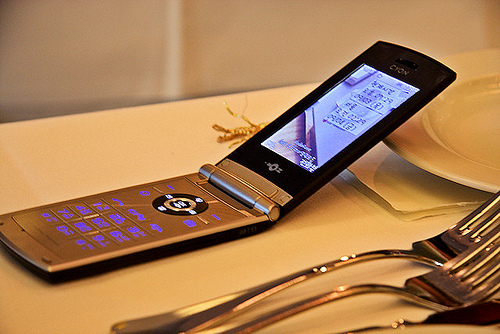<image>What is the name of the music artist that display on the MP3 player that is on the table? I don't know the name of the music artist that is displayed on the MP3 player. It could be anyone from Drake to Bruno Mars, or even an unknown foreign artist. What is the name of the music artist that display on the MP3 player that is on the table? I am not sure what is the name of the music artist that is displayed on the MP3 player. It can be seen 'drake', 'biggie smalls', 'foreign artist', 'kesha', 'bruno mars', or 'sting'. 